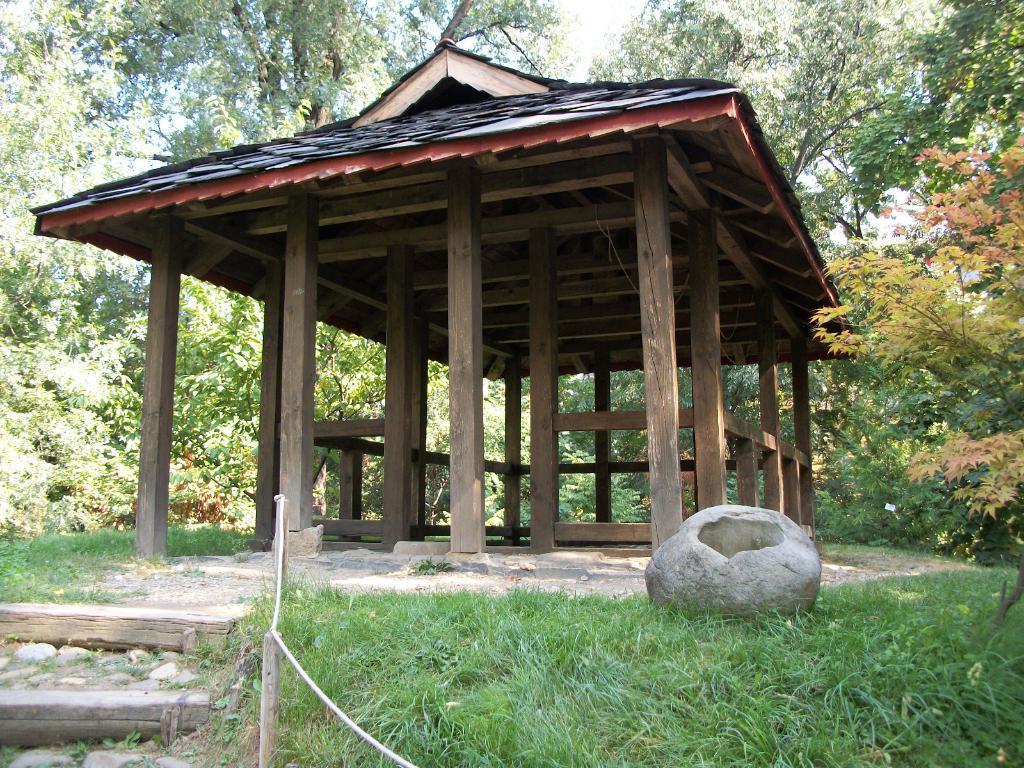In one or two sentences, can you explain what this image depicts? In the foreground of the picture we can see staircase, grass, rope, rock, wooden poles and a wooden construction. In the background there are trees, plants and sky. 